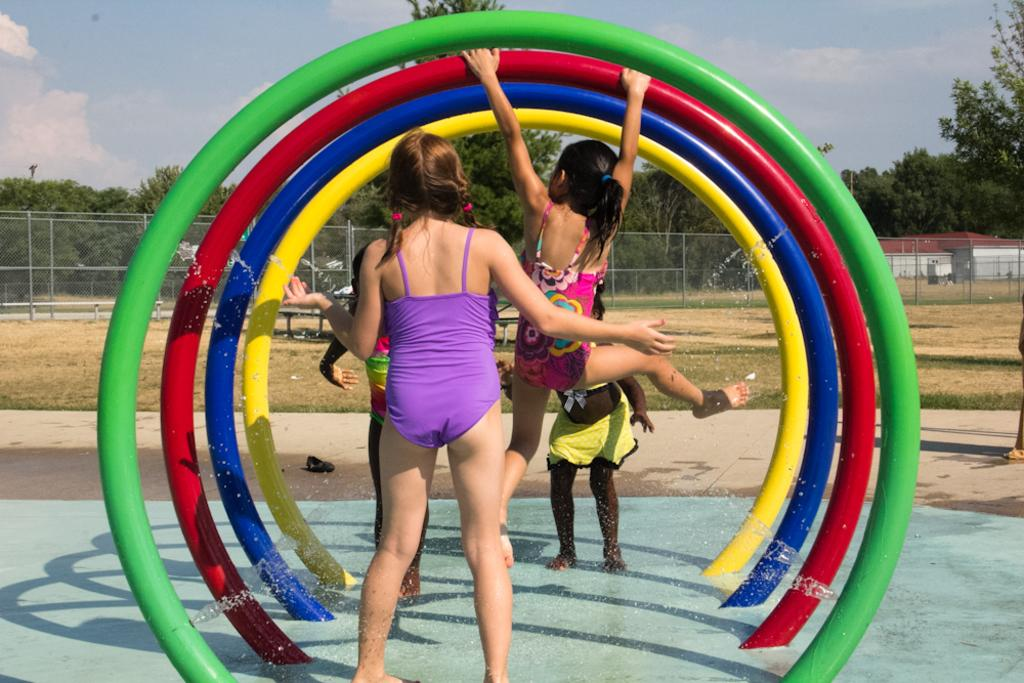How many people can be seen in the image? There are a few people in the image. What type of surface is visible on the ground? There is ground visible in the image, and it appears to be grassy. What objects are present on the ground? There are objects on the ground, but their specific nature is not mentioned in the facts. What type of vegetation is present in the image? There is grass and trees in the image. What type of structure is visible in the image? There is a house in the image. What type of barrier is present in the image? There is a fence in the image. What is visible in the sky in the image? The sky is visible in the image, and there are clouds present. How many legs can be seen on the beds in the image? There are no beds present in the image, so it is not possible to determine the number of legs on any beds. What type of relationship do the people in the image have with their brother? There is no information about the people's relationships or the presence of a brother in the image. 